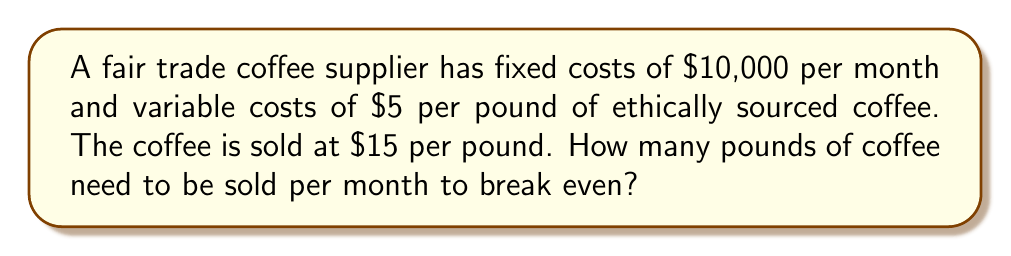Show me your answer to this math problem. To determine the break-even point, we need to find the quantity of coffee sold where total revenue equals total costs.

Let $x$ be the number of pounds of coffee sold.

1. Set up the equation:
   Total Revenue = Total Costs
   $15x = 10000 + 5x$

2. Solve for $x$:
   $15x = 10000 + 5x$
   $15x - 5x = 10000$
   $10x = 10000$

3. Divide both sides by 10:
   $x = \frac{10000}{10} = 1000$

Therefore, the supplier needs to sell 1000 pounds of coffee per month to break even.

To verify:
Revenue: $15 \times 1000 = $15,000
Costs: $10,000 + ($5 \times 1000) = $15,000

Revenue equals costs, confirming the break-even point.
Answer: 1000 pounds 